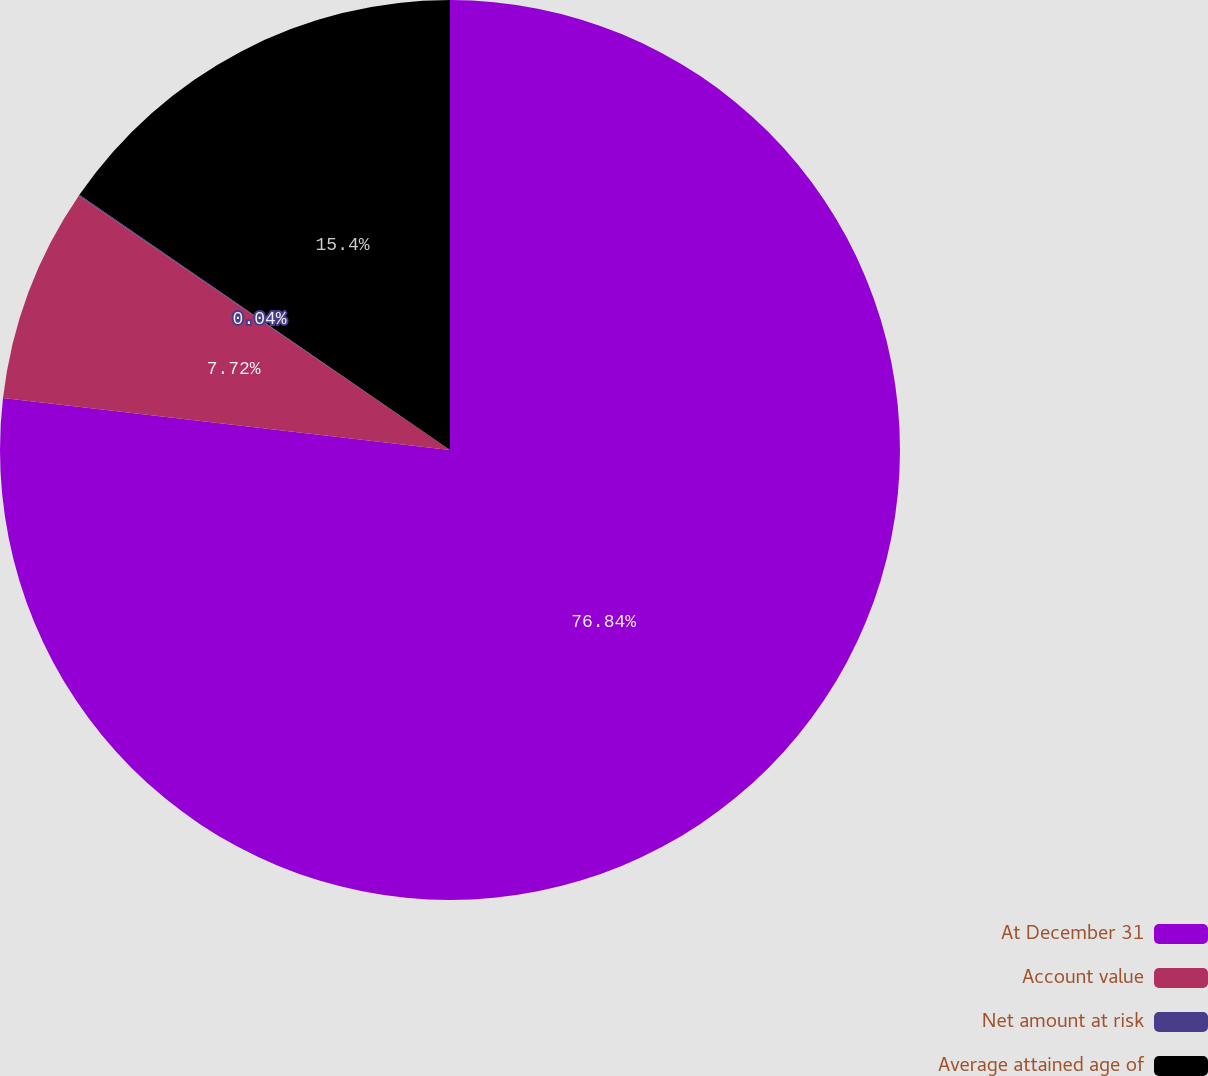Convert chart. <chart><loc_0><loc_0><loc_500><loc_500><pie_chart><fcel>At December 31<fcel>Account value<fcel>Net amount at risk<fcel>Average attained age of<nl><fcel>76.84%<fcel>7.72%<fcel>0.04%<fcel>15.4%<nl></chart> 